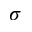Convert formula to latex. <formula><loc_0><loc_0><loc_500><loc_500>\sigma</formula> 